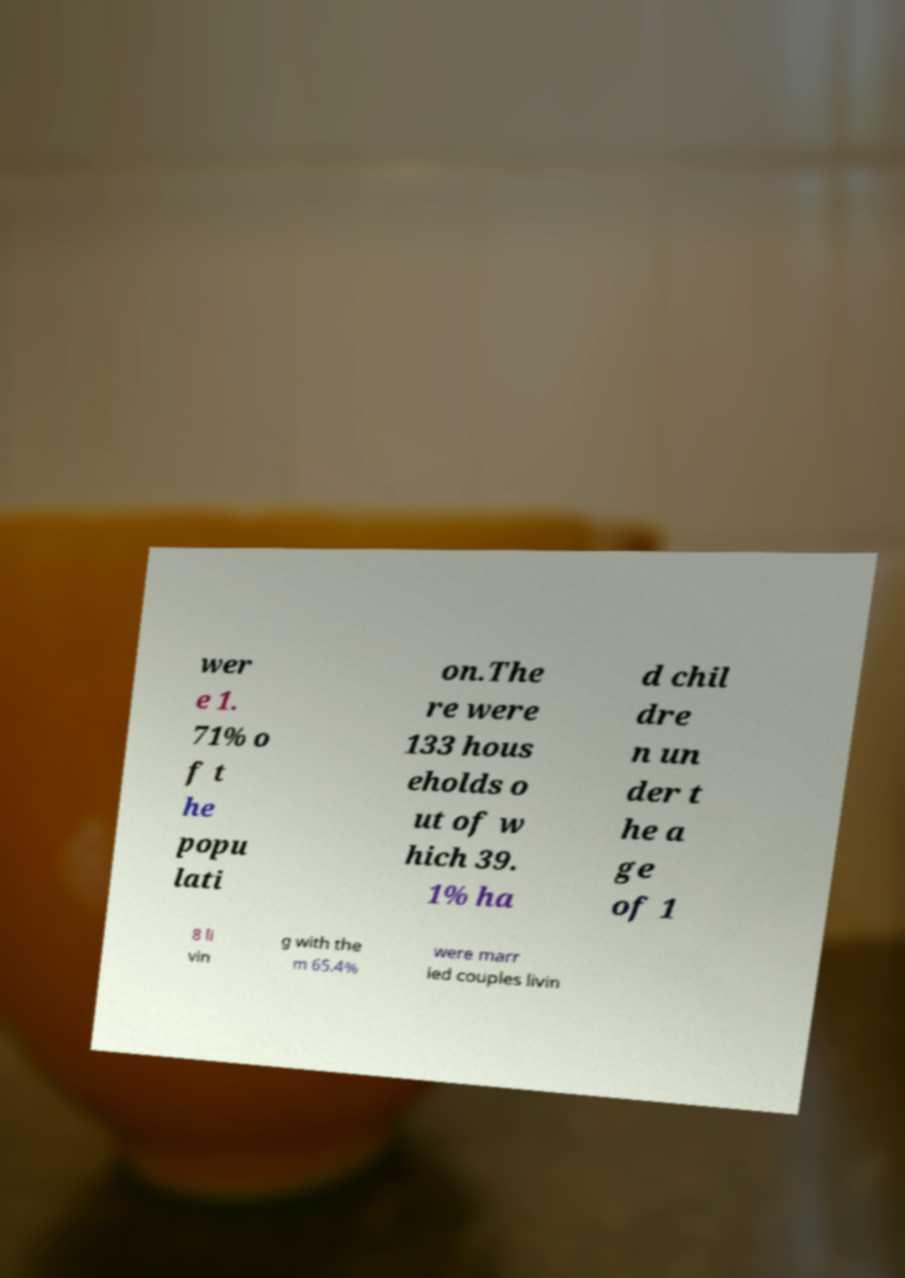Can you read and provide the text displayed in the image?This photo seems to have some interesting text. Can you extract and type it out for me? wer e 1. 71% o f t he popu lati on.The re were 133 hous eholds o ut of w hich 39. 1% ha d chil dre n un der t he a ge of 1 8 li vin g with the m 65.4% were marr ied couples livin 